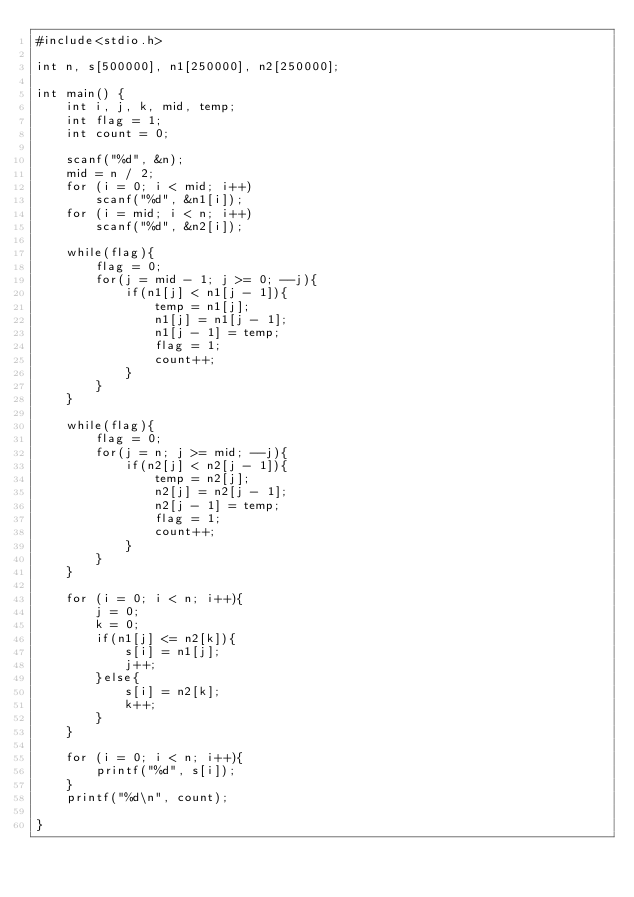Convert code to text. <code><loc_0><loc_0><loc_500><loc_500><_C_>#include<stdio.h>

int n, s[500000], n1[250000], n2[250000];

int main() {
    int i, j, k, mid, temp;
    int flag = 1;
    int count = 0;
    
    scanf("%d", &n);
    mid = n / 2;
    for (i = 0; i < mid; i++)
        scanf("%d", &n1[i]);
    for (i = mid; i < n; i++)
        scanf("%d", &n2[i]);
    
    while(flag){
        flag = 0;
        for(j = mid - 1; j >= 0; --j){
            if(n1[j] < n1[j - 1]){
                temp = n1[j];
                n1[j] = n1[j - 1];
                n1[j - 1] = temp;
                flag = 1;
                count++;
            }
        }
    }
    
    while(flag){
        flag = 0;
        for(j = n; j >= mid; --j){
            if(n2[j] < n2[j - 1]){
                temp = n2[j];
                n2[j] = n2[j - 1];
                n2[j - 1] = temp;
                flag = 1;
                count++;
            }
        }
    }
    
    for (i = 0; i < n; i++){
        j = 0;
        k = 0;
        if(n1[j] <= n2[k]){
            s[i] = n1[j];
            j++;
        }else{
            s[i] = n2[k];
            k++;
        }
    }
    
    for (i = 0; i < n; i++){
        printf("%d", s[i]);
    }
    printf("%d\n", count);
    
}</code> 